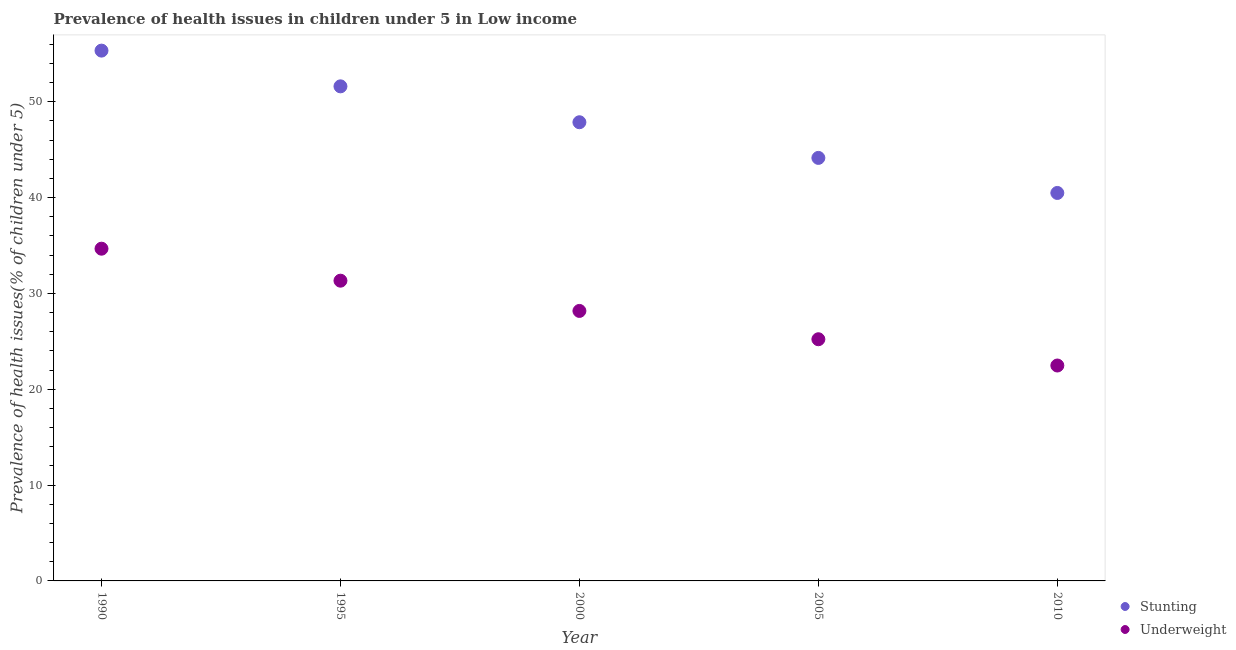What is the percentage of underweight children in 2005?
Your answer should be very brief. 25.21. Across all years, what is the maximum percentage of underweight children?
Provide a short and direct response. 34.66. Across all years, what is the minimum percentage of stunted children?
Keep it short and to the point. 40.48. In which year was the percentage of stunted children maximum?
Make the answer very short. 1990. In which year was the percentage of underweight children minimum?
Offer a very short reply. 2010. What is the total percentage of stunted children in the graph?
Ensure brevity in your answer.  239.39. What is the difference between the percentage of underweight children in 2005 and that in 2010?
Your response must be concise. 2.74. What is the difference between the percentage of stunted children in 2010 and the percentage of underweight children in 2000?
Your response must be concise. 12.31. What is the average percentage of stunted children per year?
Your answer should be very brief. 47.88. In the year 2000, what is the difference between the percentage of stunted children and percentage of underweight children?
Ensure brevity in your answer.  19.69. In how many years, is the percentage of underweight children greater than 28 %?
Keep it short and to the point. 3. What is the ratio of the percentage of stunted children in 2005 to that in 2010?
Your response must be concise. 1.09. Is the percentage of underweight children in 2000 less than that in 2005?
Ensure brevity in your answer.  No. What is the difference between the highest and the second highest percentage of underweight children?
Make the answer very short. 3.34. What is the difference between the highest and the lowest percentage of stunted children?
Your answer should be compact. 14.85. In how many years, is the percentage of stunted children greater than the average percentage of stunted children taken over all years?
Offer a terse response. 2. Is the sum of the percentage of stunted children in 1995 and 2010 greater than the maximum percentage of underweight children across all years?
Your answer should be very brief. Yes. Does the percentage of underweight children monotonically increase over the years?
Ensure brevity in your answer.  No. How many dotlines are there?
Provide a succinct answer. 2. How many years are there in the graph?
Your response must be concise. 5. What is the difference between two consecutive major ticks on the Y-axis?
Make the answer very short. 10. Does the graph contain any zero values?
Provide a short and direct response. No. Does the graph contain grids?
Provide a succinct answer. No. Where does the legend appear in the graph?
Your response must be concise. Bottom right. How many legend labels are there?
Your response must be concise. 2. What is the title of the graph?
Make the answer very short. Prevalence of health issues in children under 5 in Low income. What is the label or title of the X-axis?
Provide a succinct answer. Year. What is the label or title of the Y-axis?
Your response must be concise. Prevalence of health issues(% of children under 5). What is the Prevalence of health issues(% of children under 5) in Stunting in 1990?
Your answer should be very brief. 55.33. What is the Prevalence of health issues(% of children under 5) of Underweight in 1990?
Ensure brevity in your answer.  34.66. What is the Prevalence of health issues(% of children under 5) in Stunting in 1995?
Your answer should be very brief. 51.6. What is the Prevalence of health issues(% of children under 5) in Underweight in 1995?
Make the answer very short. 31.32. What is the Prevalence of health issues(% of children under 5) of Stunting in 2000?
Provide a short and direct response. 47.85. What is the Prevalence of health issues(% of children under 5) in Underweight in 2000?
Give a very brief answer. 28.17. What is the Prevalence of health issues(% of children under 5) in Stunting in 2005?
Your response must be concise. 44.13. What is the Prevalence of health issues(% of children under 5) in Underweight in 2005?
Your answer should be very brief. 25.21. What is the Prevalence of health issues(% of children under 5) of Stunting in 2010?
Your response must be concise. 40.48. What is the Prevalence of health issues(% of children under 5) in Underweight in 2010?
Offer a terse response. 22.47. Across all years, what is the maximum Prevalence of health issues(% of children under 5) of Stunting?
Ensure brevity in your answer.  55.33. Across all years, what is the maximum Prevalence of health issues(% of children under 5) of Underweight?
Your answer should be very brief. 34.66. Across all years, what is the minimum Prevalence of health issues(% of children under 5) in Stunting?
Offer a terse response. 40.48. Across all years, what is the minimum Prevalence of health issues(% of children under 5) of Underweight?
Your response must be concise. 22.47. What is the total Prevalence of health issues(% of children under 5) in Stunting in the graph?
Give a very brief answer. 239.39. What is the total Prevalence of health issues(% of children under 5) in Underweight in the graph?
Provide a succinct answer. 141.84. What is the difference between the Prevalence of health issues(% of children under 5) in Stunting in 1990 and that in 1995?
Provide a succinct answer. 3.73. What is the difference between the Prevalence of health issues(% of children under 5) of Underweight in 1990 and that in 1995?
Ensure brevity in your answer.  3.34. What is the difference between the Prevalence of health issues(% of children under 5) of Stunting in 1990 and that in 2000?
Offer a terse response. 7.47. What is the difference between the Prevalence of health issues(% of children under 5) in Underweight in 1990 and that in 2000?
Your response must be concise. 6.49. What is the difference between the Prevalence of health issues(% of children under 5) of Stunting in 1990 and that in 2005?
Provide a succinct answer. 11.19. What is the difference between the Prevalence of health issues(% of children under 5) of Underweight in 1990 and that in 2005?
Your answer should be very brief. 9.45. What is the difference between the Prevalence of health issues(% of children under 5) of Stunting in 1990 and that in 2010?
Give a very brief answer. 14.85. What is the difference between the Prevalence of health issues(% of children under 5) in Underweight in 1990 and that in 2010?
Give a very brief answer. 12.19. What is the difference between the Prevalence of health issues(% of children under 5) of Stunting in 1995 and that in 2000?
Ensure brevity in your answer.  3.74. What is the difference between the Prevalence of health issues(% of children under 5) in Underweight in 1995 and that in 2000?
Make the answer very short. 3.16. What is the difference between the Prevalence of health issues(% of children under 5) of Stunting in 1995 and that in 2005?
Your response must be concise. 7.47. What is the difference between the Prevalence of health issues(% of children under 5) of Underweight in 1995 and that in 2005?
Provide a succinct answer. 6.11. What is the difference between the Prevalence of health issues(% of children under 5) of Stunting in 1995 and that in 2010?
Give a very brief answer. 11.12. What is the difference between the Prevalence of health issues(% of children under 5) in Underweight in 1995 and that in 2010?
Your answer should be very brief. 8.85. What is the difference between the Prevalence of health issues(% of children under 5) of Stunting in 2000 and that in 2005?
Your answer should be very brief. 3.72. What is the difference between the Prevalence of health issues(% of children under 5) of Underweight in 2000 and that in 2005?
Your answer should be very brief. 2.95. What is the difference between the Prevalence of health issues(% of children under 5) in Stunting in 2000 and that in 2010?
Offer a terse response. 7.38. What is the difference between the Prevalence of health issues(% of children under 5) of Underweight in 2000 and that in 2010?
Ensure brevity in your answer.  5.7. What is the difference between the Prevalence of health issues(% of children under 5) in Stunting in 2005 and that in 2010?
Keep it short and to the point. 3.66. What is the difference between the Prevalence of health issues(% of children under 5) of Underweight in 2005 and that in 2010?
Give a very brief answer. 2.74. What is the difference between the Prevalence of health issues(% of children under 5) of Stunting in 1990 and the Prevalence of health issues(% of children under 5) of Underweight in 1995?
Make the answer very short. 24. What is the difference between the Prevalence of health issues(% of children under 5) in Stunting in 1990 and the Prevalence of health issues(% of children under 5) in Underweight in 2000?
Make the answer very short. 27.16. What is the difference between the Prevalence of health issues(% of children under 5) in Stunting in 1990 and the Prevalence of health issues(% of children under 5) in Underweight in 2005?
Offer a very short reply. 30.11. What is the difference between the Prevalence of health issues(% of children under 5) in Stunting in 1990 and the Prevalence of health issues(% of children under 5) in Underweight in 2010?
Provide a short and direct response. 32.85. What is the difference between the Prevalence of health issues(% of children under 5) in Stunting in 1995 and the Prevalence of health issues(% of children under 5) in Underweight in 2000?
Your response must be concise. 23.43. What is the difference between the Prevalence of health issues(% of children under 5) of Stunting in 1995 and the Prevalence of health issues(% of children under 5) of Underweight in 2005?
Your response must be concise. 26.38. What is the difference between the Prevalence of health issues(% of children under 5) in Stunting in 1995 and the Prevalence of health issues(% of children under 5) in Underweight in 2010?
Provide a short and direct response. 29.13. What is the difference between the Prevalence of health issues(% of children under 5) of Stunting in 2000 and the Prevalence of health issues(% of children under 5) of Underweight in 2005?
Give a very brief answer. 22.64. What is the difference between the Prevalence of health issues(% of children under 5) of Stunting in 2000 and the Prevalence of health issues(% of children under 5) of Underweight in 2010?
Make the answer very short. 25.38. What is the difference between the Prevalence of health issues(% of children under 5) in Stunting in 2005 and the Prevalence of health issues(% of children under 5) in Underweight in 2010?
Provide a succinct answer. 21.66. What is the average Prevalence of health issues(% of children under 5) in Stunting per year?
Your answer should be very brief. 47.88. What is the average Prevalence of health issues(% of children under 5) in Underweight per year?
Provide a short and direct response. 28.37. In the year 1990, what is the difference between the Prevalence of health issues(% of children under 5) of Stunting and Prevalence of health issues(% of children under 5) of Underweight?
Your answer should be compact. 20.66. In the year 1995, what is the difference between the Prevalence of health issues(% of children under 5) of Stunting and Prevalence of health issues(% of children under 5) of Underweight?
Offer a terse response. 20.28. In the year 2000, what is the difference between the Prevalence of health issues(% of children under 5) of Stunting and Prevalence of health issues(% of children under 5) of Underweight?
Offer a terse response. 19.69. In the year 2005, what is the difference between the Prevalence of health issues(% of children under 5) in Stunting and Prevalence of health issues(% of children under 5) in Underweight?
Provide a succinct answer. 18.92. In the year 2010, what is the difference between the Prevalence of health issues(% of children under 5) of Stunting and Prevalence of health issues(% of children under 5) of Underweight?
Offer a terse response. 18. What is the ratio of the Prevalence of health issues(% of children under 5) of Stunting in 1990 to that in 1995?
Provide a succinct answer. 1.07. What is the ratio of the Prevalence of health issues(% of children under 5) in Underweight in 1990 to that in 1995?
Provide a short and direct response. 1.11. What is the ratio of the Prevalence of health issues(% of children under 5) in Stunting in 1990 to that in 2000?
Offer a terse response. 1.16. What is the ratio of the Prevalence of health issues(% of children under 5) in Underweight in 1990 to that in 2000?
Keep it short and to the point. 1.23. What is the ratio of the Prevalence of health issues(% of children under 5) of Stunting in 1990 to that in 2005?
Offer a terse response. 1.25. What is the ratio of the Prevalence of health issues(% of children under 5) in Underweight in 1990 to that in 2005?
Offer a terse response. 1.37. What is the ratio of the Prevalence of health issues(% of children under 5) in Stunting in 1990 to that in 2010?
Offer a very short reply. 1.37. What is the ratio of the Prevalence of health issues(% of children under 5) in Underweight in 1990 to that in 2010?
Make the answer very short. 1.54. What is the ratio of the Prevalence of health issues(% of children under 5) in Stunting in 1995 to that in 2000?
Make the answer very short. 1.08. What is the ratio of the Prevalence of health issues(% of children under 5) in Underweight in 1995 to that in 2000?
Give a very brief answer. 1.11. What is the ratio of the Prevalence of health issues(% of children under 5) of Stunting in 1995 to that in 2005?
Your answer should be very brief. 1.17. What is the ratio of the Prevalence of health issues(% of children under 5) of Underweight in 1995 to that in 2005?
Offer a very short reply. 1.24. What is the ratio of the Prevalence of health issues(% of children under 5) of Stunting in 1995 to that in 2010?
Ensure brevity in your answer.  1.27. What is the ratio of the Prevalence of health issues(% of children under 5) of Underweight in 1995 to that in 2010?
Your answer should be very brief. 1.39. What is the ratio of the Prevalence of health issues(% of children under 5) in Stunting in 2000 to that in 2005?
Keep it short and to the point. 1.08. What is the ratio of the Prevalence of health issues(% of children under 5) in Underweight in 2000 to that in 2005?
Your answer should be very brief. 1.12. What is the ratio of the Prevalence of health issues(% of children under 5) of Stunting in 2000 to that in 2010?
Ensure brevity in your answer.  1.18. What is the ratio of the Prevalence of health issues(% of children under 5) in Underweight in 2000 to that in 2010?
Your response must be concise. 1.25. What is the ratio of the Prevalence of health issues(% of children under 5) in Stunting in 2005 to that in 2010?
Provide a succinct answer. 1.09. What is the ratio of the Prevalence of health issues(% of children under 5) in Underweight in 2005 to that in 2010?
Your answer should be compact. 1.12. What is the difference between the highest and the second highest Prevalence of health issues(% of children under 5) of Stunting?
Your response must be concise. 3.73. What is the difference between the highest and the second highest Prevalence of health issues(% of children under 5) of Underweight?
Your response must be concise. 3.34. What is the difference between the highest and the lowest Prevalence of health issues(% of children under 5) in Stunting?
Your answer should be compact. 14.85. What is the difference between the highest and the lowest Prevalence of health issues(% of children under 5) in Underweight?
Give a very brief answer. 12.19. 